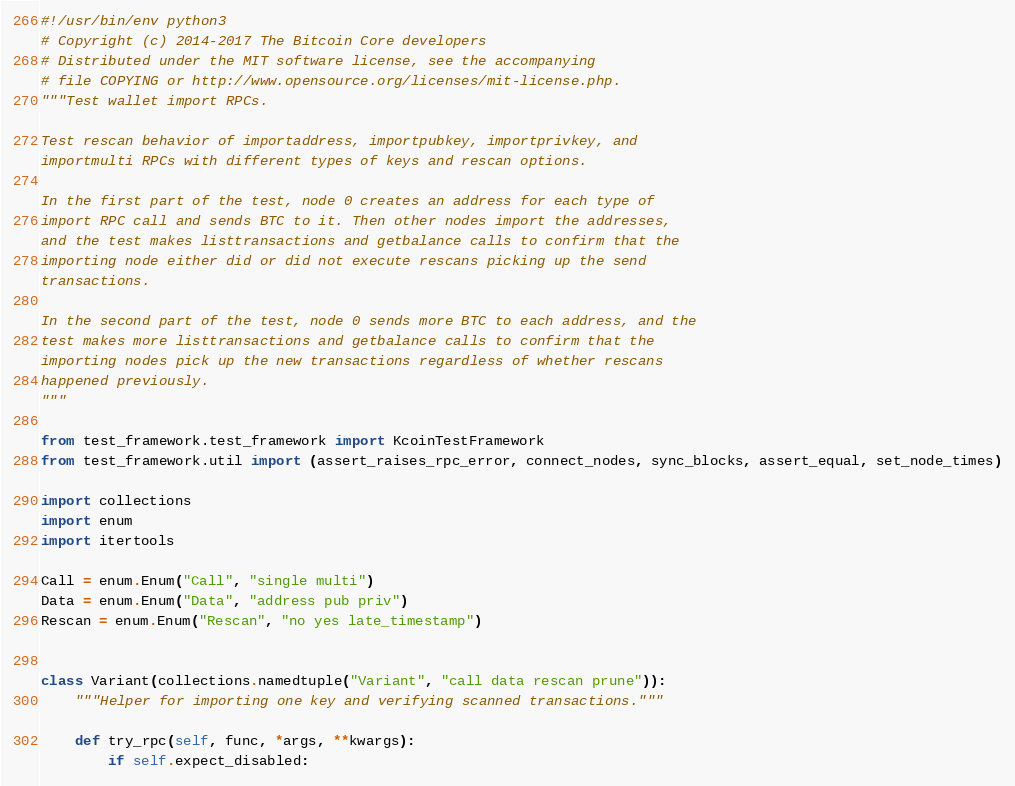Convert code to text. <code><loc_0><loc_0><loc_500><loc_500><_Python_>#!/usr/bin/env python3
# Copyright (c) 2014-2017 The Bitcoin Core developers
# Distributed under the MIT software license, see the accompanying
# file COPYING or http://www.opensource.org/licenses/mit-license.php.
"""Test wallet import RPCs.

Test rescan behavior of importaddress, importpubkey, importprivkey, and
importmulti RPCs with different types of keys and rescan options.

In the first part of the test, node 0 creates an address for each type of
import RPC call and sends BTC to it. Then other nodes import the addresses,
and the test makes listtransactions and getbalance calls to confirm that the
importing node either did or did not execute rescans picking up the send
transactions.

In the second part of the test, node 0 sends more BTC to each address, and the
test makes more listtransactions and getbalance calls to confirm that the
importing nodes pick up the new transactions regardless of whether rescans
happened previously.
"""

from test_framework.test_framework import KcoinTestFramework
from test_framework.util import (assert_raises_rpc_error, connect_nodes, sync_blocks, assert_equal, set_node_times)

import collections
import enum
import itertools

Call = enum.Enum("Call", "single multi")
Data = enum.Enum("Data", "address pub priv")
Rescan = enum.Enum("Rescan", "no yes late_timestamp")


class Variant(collections.namedtuple("Variant", "call data rescan prune")):
    """Helper for importing one key and verifying scanned transactions."""

    def try_rpc(self, func, *args, **kwargs):
        if self.expect_disabled:</code> 